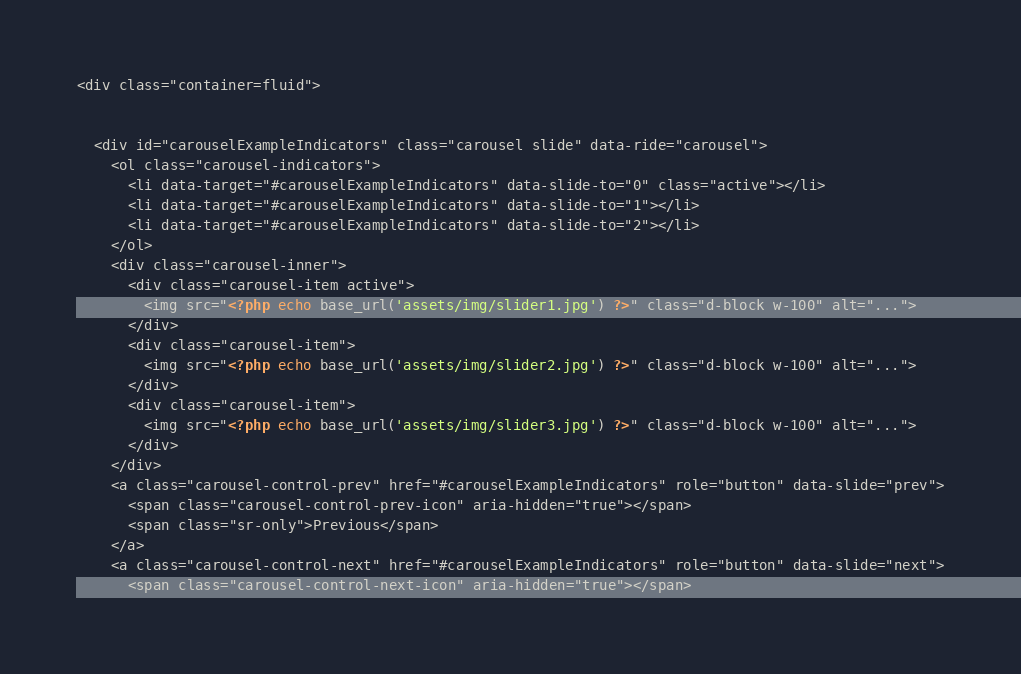Convert code to text. <code><loc_0><loc_0><loc_500><loc_500><_PHP_><div class="container=fluid">


  <div id="carouselExampleIndicators" class="carousel slide" data-ride="carousel">
    <ol class="carousel-indicators">
      <li data-target="#carouselExampleIndicators" data-slide-to="0" class="active"></li>
      <li data-target="#carouselExampleIndicators" data-slide-to="1"></li>
      <li data-target="#carouselExampleIndicators" data-slide-to="2"></li>
    </ol>
    <div class="carousel-inner">
      <div class="carousel-item active">
        <img src="<?php echo base_url('assets/img/slider1.jpg') ?>" class="d-block w-100" alt="...">
      </div>
      <div class="carousel-item">
        <img src="<?php echo base_url('assets/img/slider2.jpg') ?>" class="d-block w-100" alt="...">
      </div>
      <div class="carousel-item">
        <img src="<?php echo base_url('assets/img/slider3.jpg') ?>" class="d-block w-100" alt="...">
      </div>
    </div>
    <a class="carousel-control-prev" href="#carouselExampleIndicators" role="button" data-slide="prev">
      <span class="carousel-control-prev-icon" aria-hidden="true"></span>
      <span class="sr-only">Previous</span>
    </a>
    <a class="carousel-control-next" href="#carouselExampleIndicators" role="button" data-slide="next">
      <span class="carousel-control-next-icon" aria-hidden="true"></span></code> 